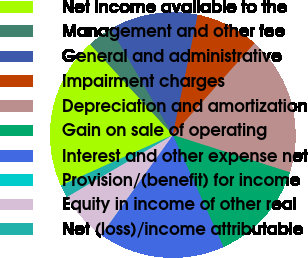Convert chart. <chart><loc_0><loc_0><loc_500><loc_500><pie_chart><fcel>Net income available to the<fcel>Management and other fee<fcel>General and administrative<fcel>Impairment charges<fcel>Depreciation and amortization<fcel>Gain on sale of operating<fcel>Interest and other expense net<fcel>Provision/(benefit) for income<fcel>Equity in income of other real<fcel>Net (loss)/income attributable<nl><fcel>19.98%<fcel>3.35%<fcel>11.66%<fcel>8.34%<fcel>18.32%<fcel>13.33%<fcel>16.65%<fcel>0.02%<fcel>6.67%<fcel>1.68%<nl></chart> 